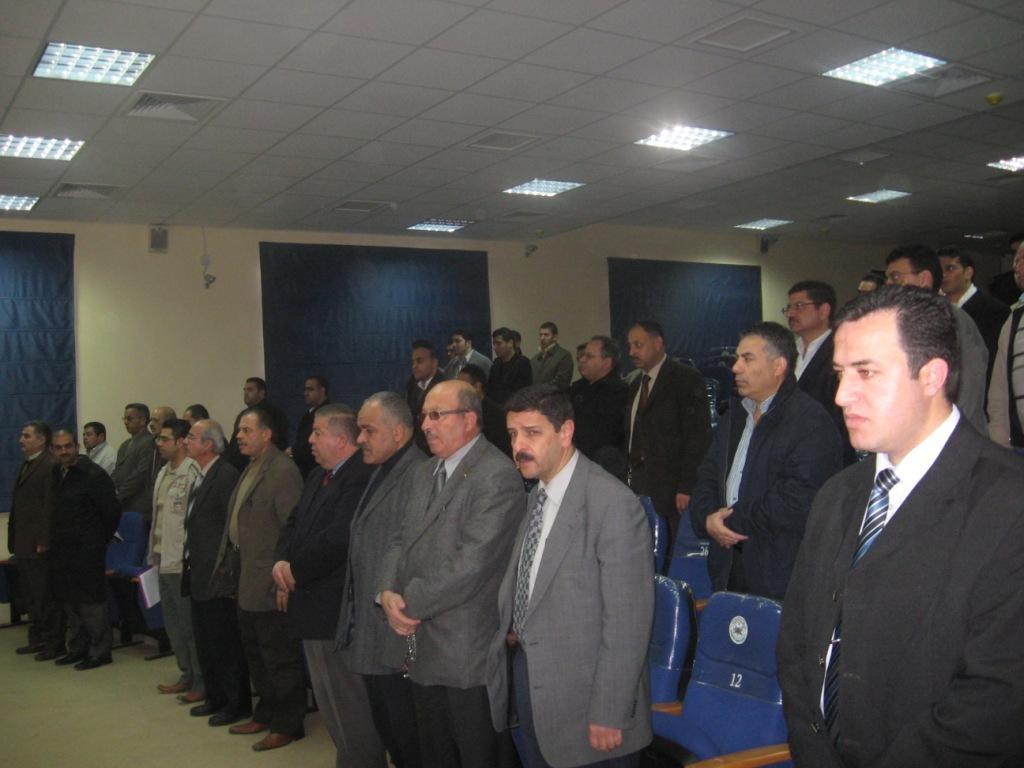Describe this image in one or two sentences. In this image I can see a group of people. I can see the chairs. At the top I can see the lights. 